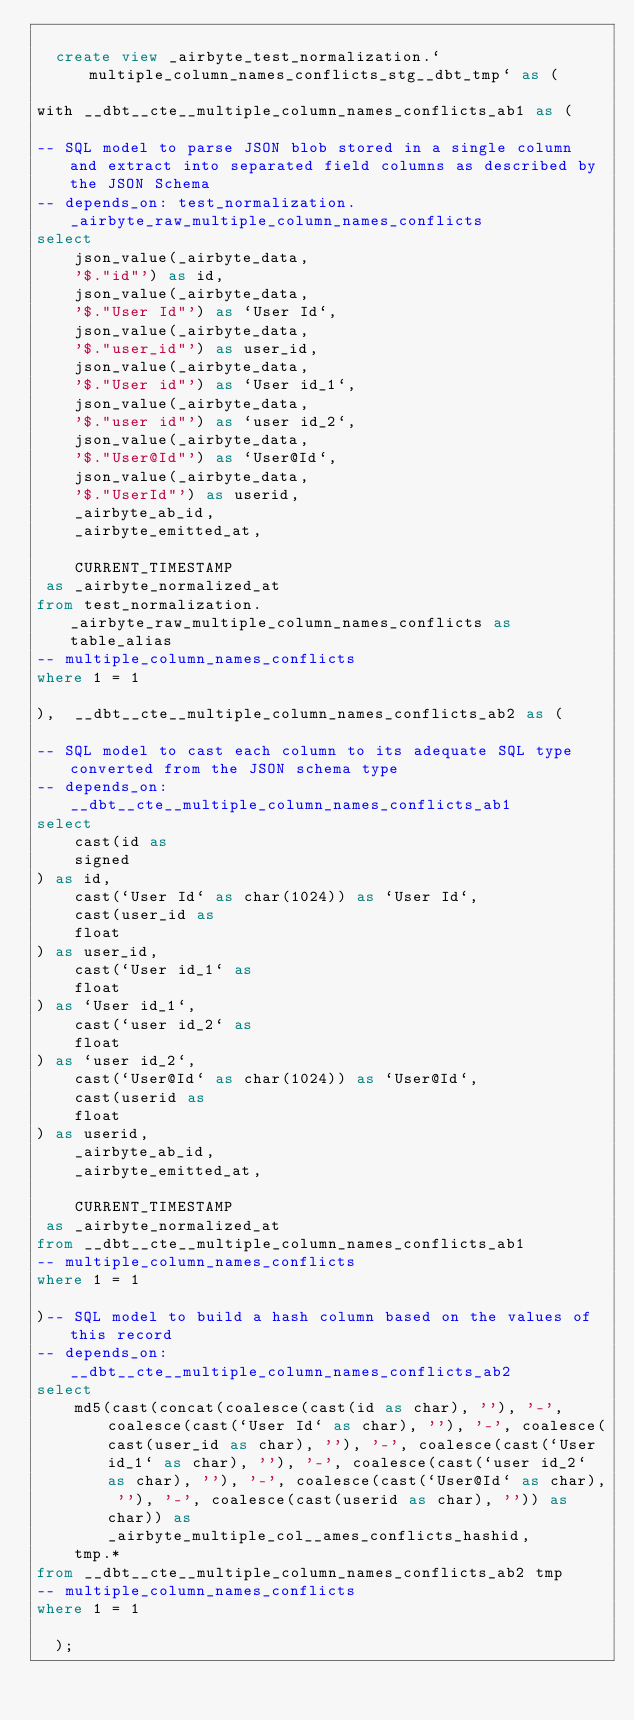Convert code to text. <code><loc_0><loc_0><loc_500><loc_500><_SQL_>
  create view _airbyte_test_normalization.`multiple_column_names_conflicts_stg__dbt_tmp` as (
    
with __dbt__cte__multiple_column_names_conflicts_ab1 as (

-- SQL model to parse JSON blob stored in a single column and extract into separated field columns as described by the JSON Schema
-- depends_on: test_normalization._airbyte_raw_multiple_column_names_conflicts
select
    json_value(_airbyte_data, 
    '$."id"') as id,
    json_value(_airbyte_data, 
    '$."User Id"') as `User Id`,
    json_value(_airbyte_data, 
    '$."user_id"') as user_id,
    json_value(_airbyte_data, 
    '$."User id"') as `User id_1`,
    json_value(_airbyte_data, 
    '$."user id"') as `user id_2`,
    json_value(_airbyte_data, 
    '$."User@Id"') as `User@Id`,
    json_value(_airbyte_data, 
    '$."UserId"') as userid,
    _airbyte_ab_id,
    _airbyte_emitted_at,
    
    CURRENT_TIMESTAMP
 as _airbyte_normalized_at
from test_normalization._airbyte_raw_multiple_column_names_conflicts as table_alias
-- multiple_column_names_conflicts
where 1 = 1

),  __dbt__cte__multiple_column_names_conflicts_ab2 as (

-- SQL model to cast each column to its adequate SQL type converted from the JSON schema type
-- depends_on: __dbt__cte__multiple_column_names_conflicts_ab1
select
    cast(id as 
    signed
) as id,
    cast(`User Id` as char(1024)) as `User Id`,
    cast(user_id as 
    float
) as user_id,
    cast(`User id_1` as 
    float
) as `User id_1`,
    cast(`user id_2` as 
    float
) as `user id_2`,
    cast(`User@Id` as char(1024)) as `User@Id`,
    cast(userid as 
    float
) as userid,
    _airbyte_ab_id,
    _airbyte_emitted_at,
    
    CURRENT_TIMESTAMP
 as _airbyte_normalized_at
from __dbt__cte__multiple_column_names_conflicts_ab1
-- multiple_column_names_conflicts
where 1 = 1

)-- SQL model to build a hash column based on the values of this record
-- depends_on: __dbt__cte__multiple_column_names_conflicts_ab2
select
    md5(cast(concat(coalesce(cast(id as char), ''), '-', coalesce(cast(`User Id` as char), ''), '-', coalesce(cast(user_id as char), ''), '-', coalesce(cast(`User id_1` as char), ''), '-', coalesce(cast(`user id_2` as char), ''), '-', coalesce(cast(`User@Id` as char), ''), '-', coalesce(cast(userid as char), '')) as char)) as _airbyte_multiple_col__ames_conflicts_hashid,
    tmp.*
from __dbt__cte__multiple_column_names_conflicts_ab2 tmp
-- multiple_column_names_conflicts
where 1 = 1

  );</code> 